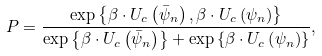<formula> <loc_0><loc_0><loc_500><loc_500>P = \frac { { \exp \left \{ { \beta \cdot { U _ { c } } \left ( { { { \bar { \psi } } _ { n } } } \right ) , \beta \cdot { U _ { c } } \left ( { \psi _ { n } } \right ) } \right \} } } { { \exp \left \{ { \beta \cdot { U _ { c } } \left ( { { { \bar { \psi } } _ { n } } } \right ) } \right \} + \exp \left \{ { \beta \cdot { U _ { c } } \left ( { \psi _ { n } } \right ) } \right \} } } ,</formula> 